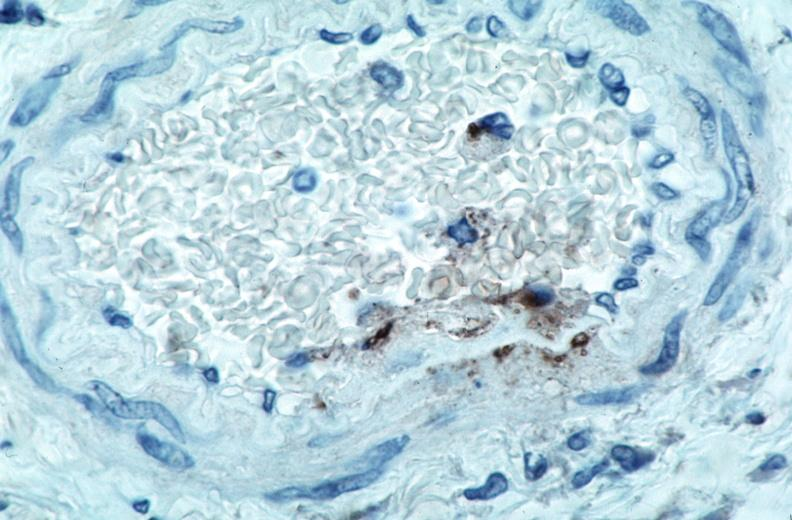what does this image show?
Answer the question using a single word or phrase. Vasculitis 